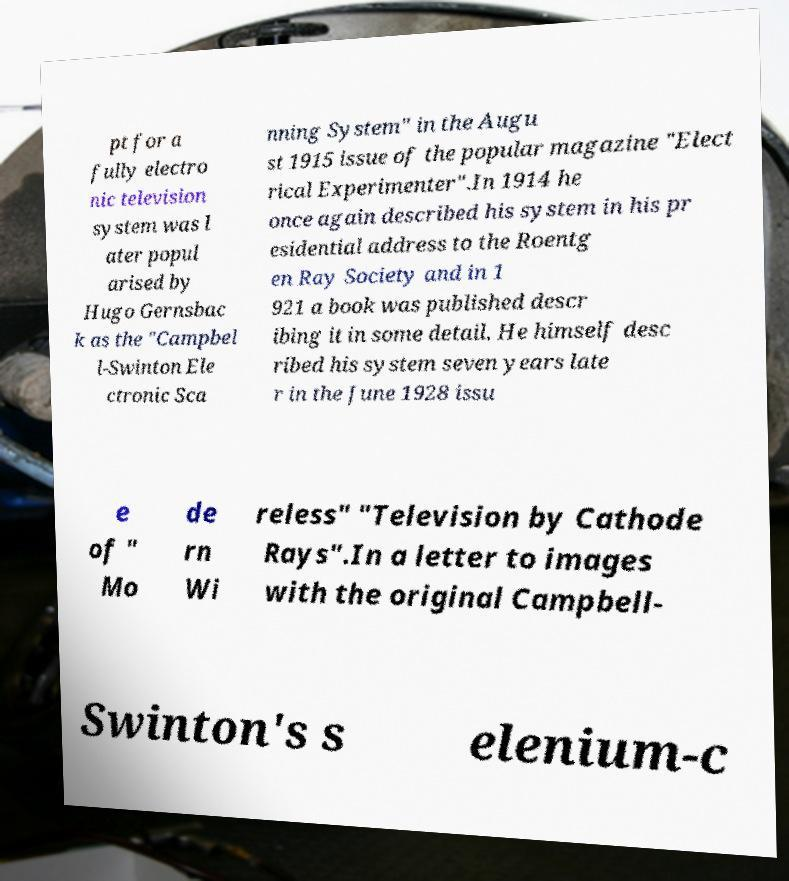Could you assist in decoding the text presented in this image and type it out clearly? pt for a fully electro nic television system was l ater popul arised by Hugo Gernsbac k as the "Campbel l-Swinton Ele ctronic Sca nning System" in the Augu st 1915 issue of the popular magazine "Elect rical Experimenter".In 1914 he once again described his system in his pr esidential address to the Roentg en Ray Society and in 1 921 a book was published descr ibing it in some detail. He himself desc ribed his system seven years late r in the June 1928 issu e of " Mo de rn Wi reless" "Television by Cathode Rays".In a letter to images with the original Campbell- Swinton's s elenium-c 